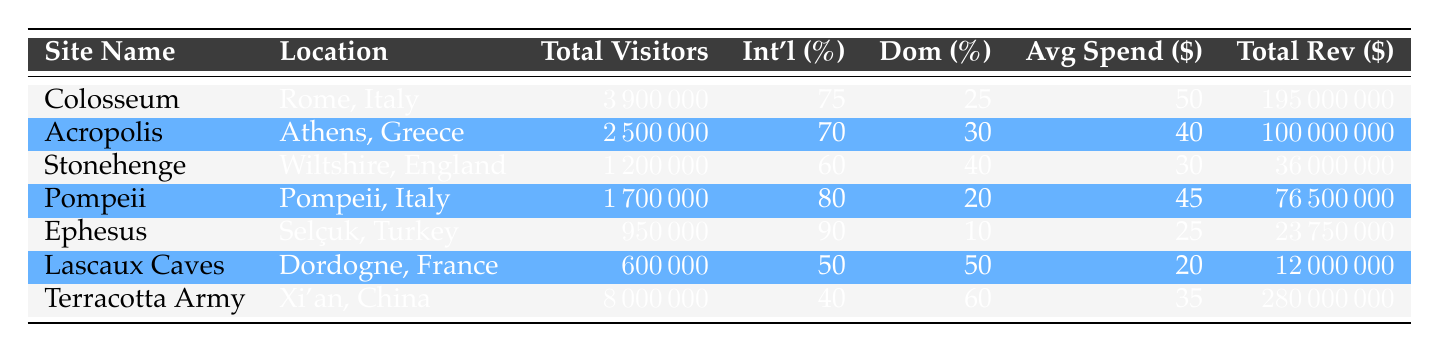What is the total revenue for the Colosseum? The revenue for the Colosseum, as listed in the table, is directly stated in the 'Total Rev ($)' column. It shows a total revenue of 195 million dollars.
Answer: 195000000 What percentage of visitors to Ephesus are domestic? The table indicates that the percentage of domestic visitors to Ephesus is 10%. This is found in the column labeled 'Dom (%)'.
Answer: 10 Which site generated the highest total revenue? By examining the 'Total Rev ($)' column in the table, I can see that the Terracotta Army, with a total revenue of 280 million dollars, has the highest value compared to the others.
Answer: Terracotta Army How many total visitors did Pompeii have? The number of visitors is stated in the 'Total Visitors' column for Pompeii, which is listed as 1,700,000.
Answer: 1700000 What is the average spending per visitor for Stonehenge? Looking at the 'Avg Spend ($)' column, the average spending per visitor at Stonehenge is found to be 30 dollars.
Answer: 30 True or False: The Acropolis has more international visitors than domestic visitors. The table shows that the percentage of international visitors to the Acropolis is 70% while domestic visitors are at 30%. Since 70% is greater than 30%, the statement is true.
Answer: True What is the total revenue generated by all sites combined? To find the total revenue for all sites, I would sum the revenues listed in the 'Total Rev ($)' column: 195000000 + 100000000 + 36000000 + 76500000 + 23750000 + 12000000 + 280000000 = 695500000.
Answer: 695500000 Which site has the highest percentage of international visitors? By scanning the 'Int'l (%)' column, Ephesus has the highest percentage of international visitors at 90%.
Answer: Ephesus How does the average spending per visitor at the Terracotta Army compare to that of the Lascaux Caves? Looking at their respective 'Avg Spend ($)' values, the Terracotta Army has an average spending of 35 dollars per visitor, while the Lascaux Caves have 20 dollars. The Terracotta Army's spending is 15 dollars higher than that of the Lascaux Caves.
Answer: 15 